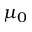Convert formula to latex. <formula><loc_0><loc_0><loc_500><loc_500>\mu _ { 0 }</formula> 